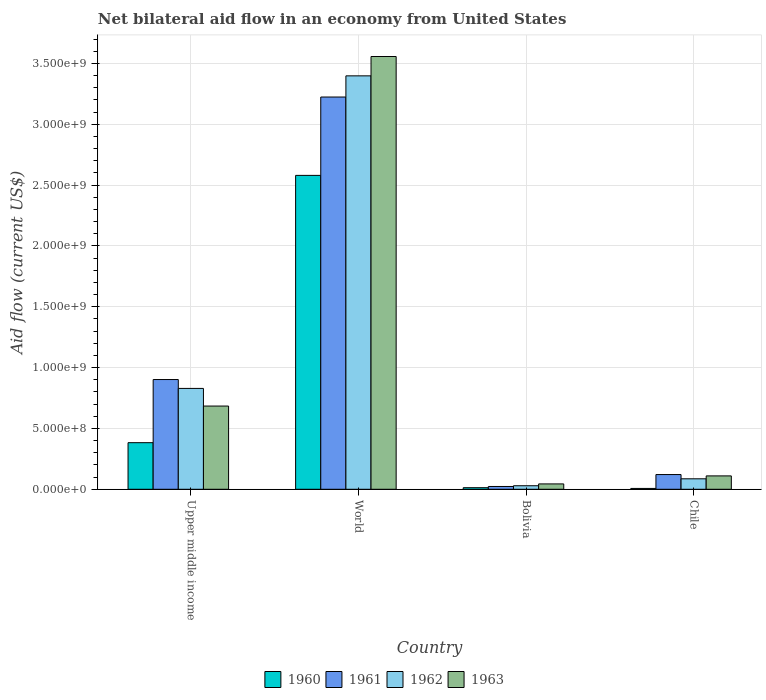How many groups of bars are there?
Keep it short and to the point. 4. Are the number of bars per tick equal to the number of legend labels?
Offer a very short reply. Yes. Are the number of bars on each tick of the X-axis equal?
Your answer should be very brief. Yes. How many bars are there on the 4th tick from the right?
Offer a very short reply. 4. What is the label of the 4th group of bars from the left?
Ensure brevity in your answer.  Chile. What is the net bilateral aid flow in 1961 in Upper middle income?
Offer a very short reply. 9.02e+08. Across all countries, what is the maximum net bilateral aid flow in 1961?
Offer a terse response. 3.22e+09. Across all countries, what is the minimum net bilateral aid flow in 1961?
Give a very brief answer. 2.30e+07. In which country was the net bilateral aid flow in 1962 maximum?
Offer a very short reply. World. In which country was the net bilateral aid flow in 1961 minimum?
Ensure brevity in your answer.  Bolivia. What is the total net bilateral aid flow in 1961 in the graph?
Offer a very short reply. 4.27e+09. What is the difference between the net bilateral aid flow in 1961 in Bolivia and that in Chile?
Give a very brief answer. -9.80e+07. What is the difference between the net bilateral aid flow in 1960 in Bolivia and the net bilateral aid flow in 1962 in World?
Offer a terse response. -3.38e+09. What is the average net bilateral aid flow in 1960 per country?
Your response must be concise. 7.46e+08. What is the difference between the net bilateral aid flow of/in 1961 and net bilateral aid flow of/in 1960 in Upper middle income?
Provide a succinct answer. 5.19e+08. What is the ratio of the net bilateral aid flow in 1962 in Bolivia to that in Chile?
Ensure brevity in your answer.  0.34. Is the net bilateral aid flow in 1962 in Chile less than that in Upper middle income?
Offer a very short reply. Yes. Is the difference between the net bilateral aid flow in 1961 in Bolivia and World greater than the difference between the net bilateral aid flow in 1960 in Bolivia and World?
Provide a succinct answer. No. What is the difference between the highest and the second highest net bilateral aid flow in 1961?
Give a very brief answer. 3.10e+09. What is the difference between the highest and the lowest net bilateral aid flow in 1961?
Provide a short and direct response. 3.20e+09. In how many countries, is the net bilateral aid flow in 1960 greater than the average net bilateral aid flow in 1960 taken over all countries?
Offer a very short reply. 1. Is it the case that in every country, the sum of the net bilateral aid flow in 1961 and net bilateral aid flow in 1960 is greater than the sum of net bilateral aid flow in 1962 and net bilateral aid flow in 1963?
Offer a terse response. No. What does the 2nd bar from the left in World represents?
Offer a very short reply. 1961. What does the 3rd bar from the right in Upper middle income represents?
Provide a short and direct response. 1961. Is it the case that in every country, the sum of the net bilateral aid flow in 1962 and net bilateral aid flow in 1963 is greater than the net bilateral aid flow in 1961?
Your answer should be very brief. Yes. How many bars are there?
Your answer should be very brief. 16. How many countries are there in the graph?
Your answer should be compact. 4. What is the difference between two consecutive major ticks on the Y-axis?
Your response must be concise. 5.00e+08. Does the graph contain grids?
Give a very brief answer. Yes. How many legend labels are there?
Ensure brevity in your answer.  4. How are the legend labels stacked?
Your answer should be very brief. Horizontal. What is the title of the graph?
Offer a terse response. Net bilateral aid flow in an economy from United States. What is the label or title of the X-axis?
Offer a terse response. Country. What is the Aid flow (current US$) in 1960 in Upper middle income?
Your response must be concise. 3.83e+08. What is the Aid flow (current US$) of 1961 in Upper middle income?
Keep it short and to the point. 9.02e+08. What is the Aid flow (current US$) of 1962 in Upper middle income?
Offer a very short reply. 8.29e+08. What is the Aid flow (current US$) in 1963 in Upper middle income?
Offer a terse response. 6.84e+08. What is the Aid flow (current US$) of 1960 in World?
Provide a short and direct response. 2.58e+09. What is the Aid flow (current US$) of 1961 in World?
Ensure brevity in your answer.  3.22e+09. What is the Aid flow (current US$) of 1962 in World?
Give a very brief answer. 3.40e+09. What is the Aid flow (current US$) of 1963 in World?
Provide a short and direct response. 3.56e+09. What is the Aid flow (current US$) of 1960 in Bolivia?
Provide a succinct answer. 1.30e+07. What is the Aid flow (current US$) in 1961 in Bolivia?
Offer a terse response. 2.30e+07. What is the Aid flow (current US$) of 1962 in Bolivia?
Provide a succinct answer. 2.90e+07. What is the Aid flow (current US$) in 1963 in Bolivia?
Your response must be concise. 4.40e+07. What is the Aid flow (current US$) of 1961 in Chile?
Provide a short and direct response. 1.21e+08. What is the Aid flow (current US$) of 1962 in Chile?
Make the answer very short. 8.60e+07. What is the Aid flow (current US$) of 1963 in Chile?
Your response must be concise. 1.10e+08. Across all countries, what is the maximum Aid flow (current US$) of 1960?
Your answer should be compact. 2.58e+09. Across all countries, what is the maximum Aid flow (current US$) in 1961?
Your response must be concise. 3.22e+09. Across all countries, what is the maximum Aid flow (current US$) in 1962?
Make the answer very short. 3.40e+09. Across all countries, what is the maximum Aid flow (current US$) of 1963?
Offer a terse response. 3.56e+09. Across all countries, what is the minimum Aid flow (current US$) of 1960?
Provide a short and direct response. 7.00e+06. Across all countries, what is the minimum Aid flow (current US$) of 1961?
Your answer should be very brief. 2.30e+07. Across all countries, what is the minimum Aid flow (current US$) of 1962?
Offer a very short reply. 2.90e+07. Across all countries, what is the minimum Aid flow (current US$) in 1963?
Keep it short and to the point. 4.40e+07. What is the total Aid flow (current US$) of 1960 in the graph?
Provide a short and direct response. 2.98e+09. What is the total Aid flow (current US$) in 1961 in the graph?
Provide a short and direct response. 4.27e+09. What is the total Aid flow (current US$) of 1962 in the graph?
Provide a short and direct response. 4.34e+09. What is the total Aid flow (current US$) of 1963 in the graph?
Provide a short and direct response. 4.40e+09. What is the difference between the Aid flow (current US$) in 1960 in Upper middle income and that in World?
Give a very brief answer. -2.20e+09. What is the difference between the Aid flow (current US$) of 1961 in Upper middle income and that in World?
Offer a terse response. -2.32e+09. What is the difference between the Aid flow (current US$) of 1962 in Upper middle income and that in World?
Provide a succinct answer. -2.57e+09. What is the difference between the Aid flow (current US$) in 1963 in Upper middle income and that in World?
Your answer should be very brief. -2.87e+09. What is the difference between the Aid flow (current US$) of 1960 in Upper middle income and that in Bolivia?
Offer a terse response. 3.70e+08. What is the difference between the Aid flow (current US$) in 1961 in Upper middle income and that in Bolivia?
Make the answer very short. 8.79e+08. What is the difference between the Aid flow (current US$) of 1962 in Upper middle income and that in Bolivia?
Offer a very short reply. 8.00e+08. What is the difference between the Aid flow (current US$) in 1963 in Upper middle income and that in Bolivia?
Keep it short and to the point. 6.40e+08. What is the difference between the Aid flow (current US$) of 1960 in Upper middle income and that in Chile?
Your answer should be compact. 3.76e+08. What is the difference between the Aid flow (current US$) of 1961 in Upper middle income and that in Chile?
Ensure brevity in your answer.  7.81e+08. What is the difference between the Aid flow (current US$) in 1962 in Upper middle income and that in Chile?
Offer a terse response. 7.43e+08. What is the difference between the Aid flow (current US$) in 1963 in Upper middle income and that in Chile?
Offer a very short reply. 5.74e+08. What is the difference between the Aid flow (current US$) of 1960 in World and that in Bolivia?
Keep it short and to the point. 2.57e+09. What is the difference between the Aid flow (current US$) of 1961 in World and that in Bolivia?
Provide a short and direct response. 3.20e+09. What is the difference between the Aid flow (current US$) in 1962 in World and that in Bolivia?
Give a very brief answer. 3.37e+09. What is the difference between the Aid flow (current US$) in 1963 in World and that in Bolivia?
Provide a short and direct response. 3.51e+09. What is the difference between the Aid flow (current US$) in 1960 in World and that in Chile?
Offer a terse response. 2.57e+09. What is the difference between the Aid flow (current US$) of 1961 in World and that in Chile?
Ensure brevity in your answer.  3.10e+09. What is the difference between the Aid flow (current US$) in 1962 in World and that in Chile?
Make the answer very short. 3.31e+09. What is the difference between the Aid flow (current US$) of 1963 in World and that in Chile?
Offer a very short reply. 3.45e+09. What is the difference between the Aid flow (current US$) in 1960 in Bolivia and that in Chile?
Make the answer very short. 6.00e+06. What is the difference between the Aid flow (current US$) of 1961 in Bolivia and that in Chile?
Offer a very short reply. -9.80e+07. What is the difference between the Aid flow (current US$) of 1962 in Bolivia and that in Chile?
Offer a very short reply. -5.70e+07. What is the difference between the Aid flow (current US$) in 1963 in Bolivia and that in Chile?
Offer a terse response. -6.60e+07. What is the difference between the Aid flow (current US$) of 1960 in Upper middle income and the Aid flow (current US$) of 1961 in World?
Make the answer very short. -2.84e+09. What is the difference between the Aid flow (current US$) of 1960 in Upper middle income and the Aid flow (current US$) of 1962 in World?
Offer a terse response. -3.02e+09. What is the difference between the Aid flow (current US$) in 1960 in Upper middle income and the Aid flow (current US$) in 1963 in World?
Give a very brief answer. -3.17e+09. What is the difference between the Aid flow (current US$) in 1961 in Upper middle income and the Aid flow (current US$) in 1962 in World?
Make the answer very short. -2.50e+09. What is the difference between the Aid flow (current US$) of 1961 in Upper middle income and the Aid flow (current US$) of 1963 in World?
Your response must be concise. -2.66e+09. What is the difference between the Aid flow (current US$) in 1962 in Upper middle income and the Aid flow (current US$) in 1963 in World?
Offer a very short reply. -2.73e+09. What is the difference between the Aid flow (current US$) in 1960 in Upper middle income and the Aid flow (current US$) in 1961 in Bolivia?
Give a very brief answer. 3.60e+08. What is the difference between the Aid flow (current US$) of 1960 in Upper middle income and the Aid flow (current US$) of 1962 in Bolivia?
Your answer should be very brief. 3.54e+08. What is the difference between the Aid flow (current US$) of 1960 in Upper middle income and the Aid flow (current US$) of 1963 in Bolivia?
Your response must be concise. 3.39e+08. What is the difference between the Aid flow (current US$) in 1961 in Upper middle income and the Aid flow (current US$) in 1962 in Bolivia?
Provide a short and direct response. 8.73e+08. What is the difference between the Aid flow (current US$) of 1961 in Upper middle income and the Aid flow (current US$) of 1963 in Bolivia?
Ensure brevity in your answer.  8.58e+08. What is the difference between the Aid flow (current US$) in 1962 in Upper middle income and the Aid flow (current US$) in 1963 in Bolivia?
Keep it short and to the point. 7.85e+08. What is the difference between the Aid flow (current US$) of 1960 in Upper middle income and the Aid flow (current US$) of 1961 in Chile?
Make the answer very short. 2.62e+08. What is the difference between the Aid flow (current US$) of 1960 in Upper middle income and the Aid flow (current US$) of 1962 in Chile?
Make the answer very short. 2.97e+08. What is the difference between the Aid flow (current US$) in 1960 in Upper middle income and the Aid flow (current US$) in 1963 in Chile?
Provide a succinct answer. 2.73e+08. What is the difference between the Aid flow (current US$) in 1961 in Upper middle income and the Aid flow (current US$) in 1962 in Chile?
Your answer should be compact. 8.16e+08. What is the difference between the Aid flow (current US$) in 1961 in Upper middle income and the Aid flow (current US$) in 1963 in Chile?
Your answer should be very brief. 7.92e+08. What is the difference between the Aid flow (current US$) of 1962 in Upper middle income and the Aid flow (current US$) of 1963 in Chile?
Make the answer very short. 7.19e+08. What is the difference between the Aid flow (current US$) of 1960 in World and the Aid flow (current US$) of 1961 in Bolivia?
Ensure brevity in your answer.  2.56e+09. What is the difference between the Aid flow (current US$) in 1960 in World and the Aid flow (current US$) in 1962 in Bolivia?
Your answer should be very brief. 2.55e+09. What is the difference between the Aid flow (current US$) of 1960 in World and the Aid flow (current US$) of 1963 in Bolivia?
Your response must be concise. 2.54e+09. What is the difference between the Aid flow (current US$) in 1961 in World and the Aid flow (current US$) in 1962 in Bolivia?
Your answer should be very brief. 3.20e+09. What is the difference between the Aid flow (current US$) of 1961 in World and the Aid flow (current US$) of 1963 in Bolivia?
Your response must be concise. 3.18e+09. What is the difference between the Aid flow (current US$) of 1962 in World and the Aid flow (current US$) of 1963 in Bolivia?
Provide a succinct answer. 3.35e+09. What is the difference between the Aid flow (current US$) of 1960 in World and the Aid flow (current US$) of 1961 in Chile?
Your response must be concise. 2.46e+09. What is the difference between the Aid flow (current US$) of 1960 in World and the Aid flow (current US$) of 1962 in Chile?
Keep it short and to the point. 2.49e+09. What is the difference between the Aid flow (current US$) of 1960 in World and the Aid flow (current US$) of 1963 in Chile?
Keep it short and to the point. 2.47e+09. What is the difference between the Aid flow (current US$) in 1961 in World and the Aid flow (current US$) in 1962 in Chile?
Offer a very short reply. 3.14e+09. What is the difference between the Aid flow (current US$) in 1961 in World and the Aid flow (current US$) in 1963 in Chile?
Your response must be concise. 3.11e+09. What is the difference between the Aid flow (current US$) in 1962 in World and the Aid flow (current US$) in 1963 in Chile?
Offer a terse response. 3.29e+09. What is the difference between the Aid flow (current US$) of 1960 in Bolivia and the Aid flow (current US$) of 1961 in Chile?
Provide a short and direct response. -1.08e+08. What is the difference between the Aid flow (current US$) of 1960 in Bolivia and the Aid flow (current US$) of 1962 in Chile?
Offer a very short reply. -7.30e+07. What is the difference between the Aid flow (current US$) in 1960 in Bolivia and the Aid flow (current US$) in 1963 in Chile?
Your answer should be compact. -9.70e+07. What is the difference between the Aid flow (current US$) of 1961 in Bolivia and the Aid flow (current US$) of 1962 in Chile?
Offer a very short reply. -6.30e+07. What is the difference between the Aid flow (current US$) in 1961 in Bolivia and the Aid flow (current US$) in 1963 in Chile?
Give a very brief answer. -8.70e+07. What is the difference between the Aid flow (current US$) in 1962 in Bolivia and the Aid flow (current US$) in 1963 in Chile?
Your answer should be very brief. -8.10e+07. What is the average Aid flow (current US$) of 1960 per country?
Your answer should be compact. 7.46e+08. What is the average Aid flow (current US$) of 1961 per country?
Your answer should be very brief. 1.07e+09. What is the average Aid flow (current US$) in 1962 per country?
Provide a succinct answer. 1.09e+09. What is the average Aid flow (current US$) of 1963 per country?
Give a very brief answer. 1.10e+09. What is the difference between the Aid flow (current US$) in 1960 and Aid flow (current US$) in 1961 in Upper middle income?
Your answer should be compact. -5.19e+08. What is the difference between the Aid flow (current US$) in 1960 and Aid flow (current US$) in 1962 in Upper middle income?
Make the answer very short. -4.46e+08. What is the difference between the Aid flow (current US$) of 1960 and Aid flow (current US$) of 1963 in Upper middle income?
Your answer should be compact. -3.01e+08. What is the difference between the Aid flow (current US$) in 1961 and Aid flow (current US$) in 1962 in Upper middle income?
Keep it short and to the point. 7.30e+07. What is the difference between the Aid flow (current US$) in 1961 and Aid flow (current US$) in 1963 in Upper middle income?
Your response must be concise. 2.18e+08. What is the difference between the Aid flow (current US$) of 1962 and Aid flow (current US$) of 1963 in Upper middle income?
Offer a very short reply. 1.45e+08. What is the difference between the Aid flow (current US$) of 1960 and Aid flow (current US$) of 1961 in World?
Your response must be concise. -6.44e+08. What is the difference between the Aid flow (current US$) of 1960 and Aid flow (current US$) of 1962 in World?
Provide a succinct answer. -8.18e+08. What is the difference between the Aid flow (current US$) in 1960 and Aid flow (current US$) in 1963 in World?
Your answer should be compact. -9.77e+08. What is the difference between the Aid flow (current US$) in 1961 and Aid flow (current US$) in 1962 in World?
Keep it short and to the point. -1.74e+08. What is the difference between the Aid flow (current US$) of 1961 and Aid flow (current US$) of 1963 in World?
Your answer should be very brief. -3.33e+08. What is the difference between the Aid flow (current US$) in 1962 and Aid flow (current US$) in 1963 in World?
Keep it short and to the point. -1.59e+08. What is the difference between the Aid flow (current US$) of 1960 and Aid flow (current US$) of 1961 in Bolivia?
Provide a short and direct response. -1.00e+07. What is the difference between the Aid flow (current US$) of 1960 and Aid flow (current US$) of 1962 in Bolivia?
Make the answer very short. -1.60e+07. What is the difference between the Aid flow (current US$) in 1960 and Aid flow (current US$) in 1963 in Bolivia?
Your response must be concise. -3.10e+07. What is the difference between the Aid flow (current US$) of 1961 and Aid flow (current US$) of 1962 in Bolivia?
Your answer should be very brief. -6.00e+06. What is the difference between the Aid flow (current US$) of 1961 and Aid flow (current US$) of 1963 in Bolivia?
Your answer should be very brief. -2.10e+07. What is the difference between the Aid flow (current US$) in 1962 and Aid flow (current US$) in 1963 in Bolivia?
Keep it short and to the point. -1.50e+07. What is the difference between the Aid flow (current US$) in 1960 and Aid flow (current US$) in 1961 in Chile?
Provide a short and direct response. -1.14e+08. What is the difference between the Aid flow (current US$) in 1960 and Aid flow (current US$) in 1962 in Chile?
Provide a succinct answer. -7.90e+07. What is the difference between the Aid flow (current US$) in 1960 and Aid flow (current US$) in 1963 in Chile?
Offer a very short reply. -1.03e+08. What is the difference between the Aid flow (current US$) in 1961 and Aid flow (current US$) in 1962 in Chile?
Your answer should be very brief. 3.50e+07. What is the difference between the Aid flow (current US$) in 1961 and Aid flow (current US$) in 1963 in Chile?
Your answer should be compact. 1.10e+07. What is the difference between the Aid flow (current US$) of 1962 and Aid flow (current US$) of 1963 in Chile?
Provide a short and direct response. -2.40e+07. What is the ratio of the Aid flow (current US$) in 1960 in Upper middle income to that in World?
Provide a succinct answer. 0.15. What is the ratio of the Aid flow (current US$) in 1961 in Upper middle income to that in World?
Ensure brevity in your answer.  0.28. What is the ratio of the Aid flow (current US$) of 1962 in Upper middle income to that in World?
Offer a terse response. 0.24. What is the ratio of the Aid flow (current US$) in 1963 in Upper middle income to that in World?
Your answer should be very brief. 0.19. What is the ratio of the Aid flow (current US$) of 1960 in Upper middle income to that in Bolivia?
Provide a succinct answer. 29.46. What is the ratio of the Aid flow (current US$) of 1961 in Upper middle income to that in Bolivia?
Provide a succinct answer. 39.22. What is the ratio of the Aid flow (current US$) of 1962 in Upper middle income to that in Bolivia?
Offer a terse response. 28.59. What is the ratio of the Aid flow (current US$) in 1963 in Upper middle income to that in Bolivia?
Your response must be concise. 15.55. What is the ratio of the Aid flow (current US$) in 1960 in Upper middle income to that in Chile?
Provide a short and direct response. 54.71. What is the ratio of the Aid flow (current US$) of 1961 in Upper middle income to that in Chile?
Make the answer very short. 7.45. What is the ratio of the Aid flow (current US$) in 1962 in Upper middle income to that in Chile?
Your answer should be very brief. 9.64. What is the ratio of the Aid flow (current US$) of 1963 in Upper middle income to that in Chile?
Offer a terse response. 6.22. What is the ratio of the Aid flow (current US$) in 1960 in World to that in Bolivia?
Provide a short and direct response. 198.46. What is the ratio of the Aid flow (current US$) of 1961 in World to that in Bolivia?
Make the answer very short. 140.17. What is the ratio of the Aid flow (current US$) in 1962 in World to that in Bolivia?
Ensure brevity in your answer.  117.17. What is the ratio of the Aid flow (current US$) in 1963 in World to that in Bolivia?
Your answer should be compact. 80.84. What is the ratio of the Aid flow (current US$) in 1960 in World to that in Chile?
Make the answer very short. 368.57. What is the ratio of the Aid flow (current US$) in 1961 in World to that in Chile?
Offer a very short reply. 26.64. What is the ratio of the Aid flow (current US$) of 1962 in World to that in Chile?
Your response must be concise. 39.51. What is the ratio of the Aid flow (current US$) of 1963 in World to that in Chile?
Your response must be concise. 32.34. What is the ratio of the Aid flow (current US$) in 1960 in Bolivia to that in Chile?
Provide a short and direct response. 1.86. What is the ratio of the Aid flow (current US$) of 1961 in Bolivia to that in Chile?
Your answer should be compact. 0.19. What is the ratio of the Aid flow (current US$) in 1962 in Bolivia to that in Chile?
Provide a short and direct response. 0.34. What is the ratio of the Aid flow (current US$) of 1963 in Bolivia to that in Chile?
Provide a short and direct response. 0.4. What is the difference between the highest and the second highest Aid flow (current US$) in 1960?
Make the answer very short. 2.20e+09. What is the difference between the highest and the second highest Aid flow (current US$) of 1961?
Your answer should be compact. 2.32e+09. What is the difference between the highest and the second highest Aid flow (current US$) of 1962?
Keep it short and to the point. 2.57e+09. What is the difference between the highest and the second highest Aid flow (current US$) of 1963?
Your response must be concise. 2.87e+09. What is the difference between the highest and the lowest Aid flow (current US$) of 1960?
Keep it short and to the point. 2.57e+09. What is the difference between the highest and the lowest Aid flow (current US$) in 1961?
Make the answer very short. 3.20e+09. What is the difference between the highest and the lowest Aid flow (current US$) in 1962?
Keep it short and to the point. 3.37e+09. What is the difference between the highest and the lowest Aid flow (current US$) of 1963?
Ensure brevity in your answer.  3.51e+09. 